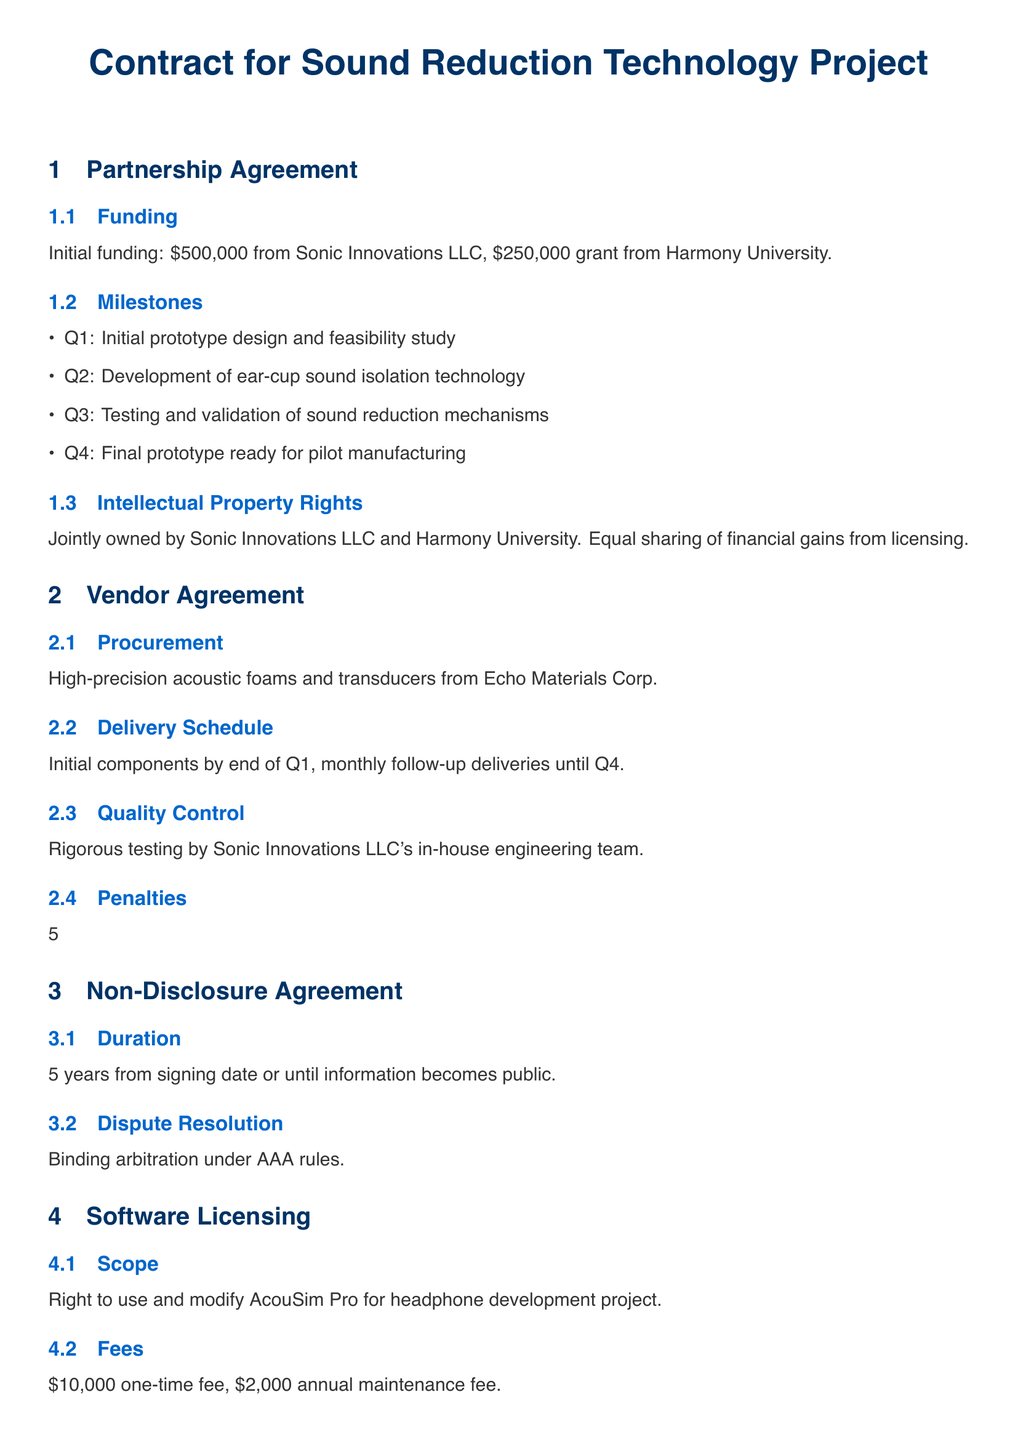What is the initial funding amount from Sonic Innovations LLC? The initial funding amount is stated in the Partnership Agreement section under Funding, which specifies a contribution of $500,000 from Sonic Innovations LLC.
Answer: $500,000 What is the penalty for delays in the Vendor Agreement? The penalties for delays are outlined in the Vendor Agreement section under Penalties, indicating a 5% penalty per week, capped at 20% of the total contract value.
Answer: 5% penalty How long is the confidentiality duration in the Non-Disclosure Agreement? The Non-Disclosure Agreement specifies that the confidentiality duration is 5 years from the signing date.
Answer: 5 years What is the total compensation package for the Senior Acoustical Engineer? The compensation package is detailed in the Employment Contract section, which includes a salary of $120,000 per annum along with benefits.
Answer: $120,000 What is the annual maintenance fee for the software licensing? The Software Licensing section states that there is a $2,000 annual maintenance fee associated with the use of AcouSim Pro.
Answer: $2,000 What are the key milestones listed in the Partnership Agreement? Key milestones are listed in the Milestones subsection, which includes four specific stages (Q1 through Q4) for the project.
Answer: Initial prototype design What is the name of the materials supplier for the acoustic components? The Vendor Agreement specifies that components will be procured from Echo Materials Corp as mentioned in the Procurement subsection.
Answer: Echo Materials Corp What does the Intellectual Property Rights section state about ownership? The Intellectual Property Rights section states that the rights will be jointly owned by Sonic Innovations LLC and Harmony University.
Answer: Jointly owned What is the dispute resolution method stated in the NDA? The Non-Disclosure Agreement mentions binding arbitration under AAA rules as the method for dispute resolution.
Answer: Binding arbitration 